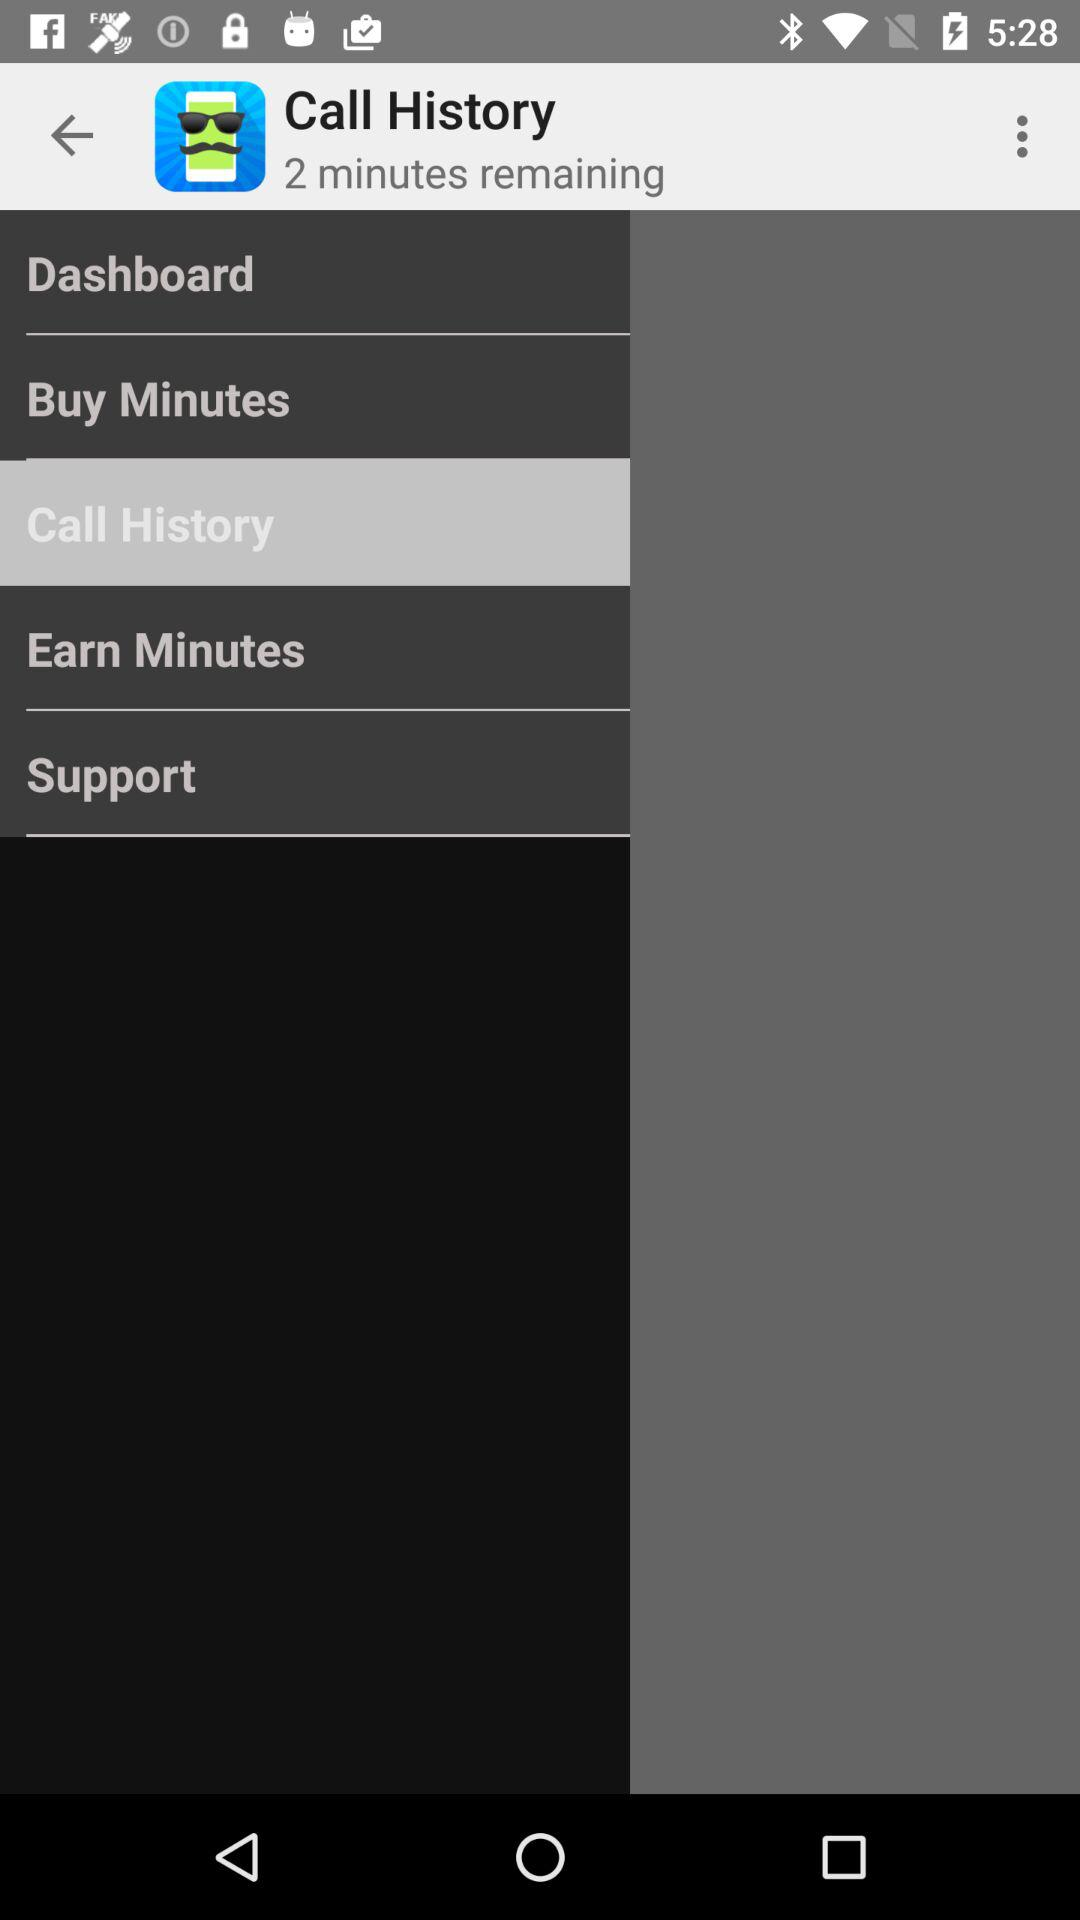What is the selected item? The selected item is "Call History". 